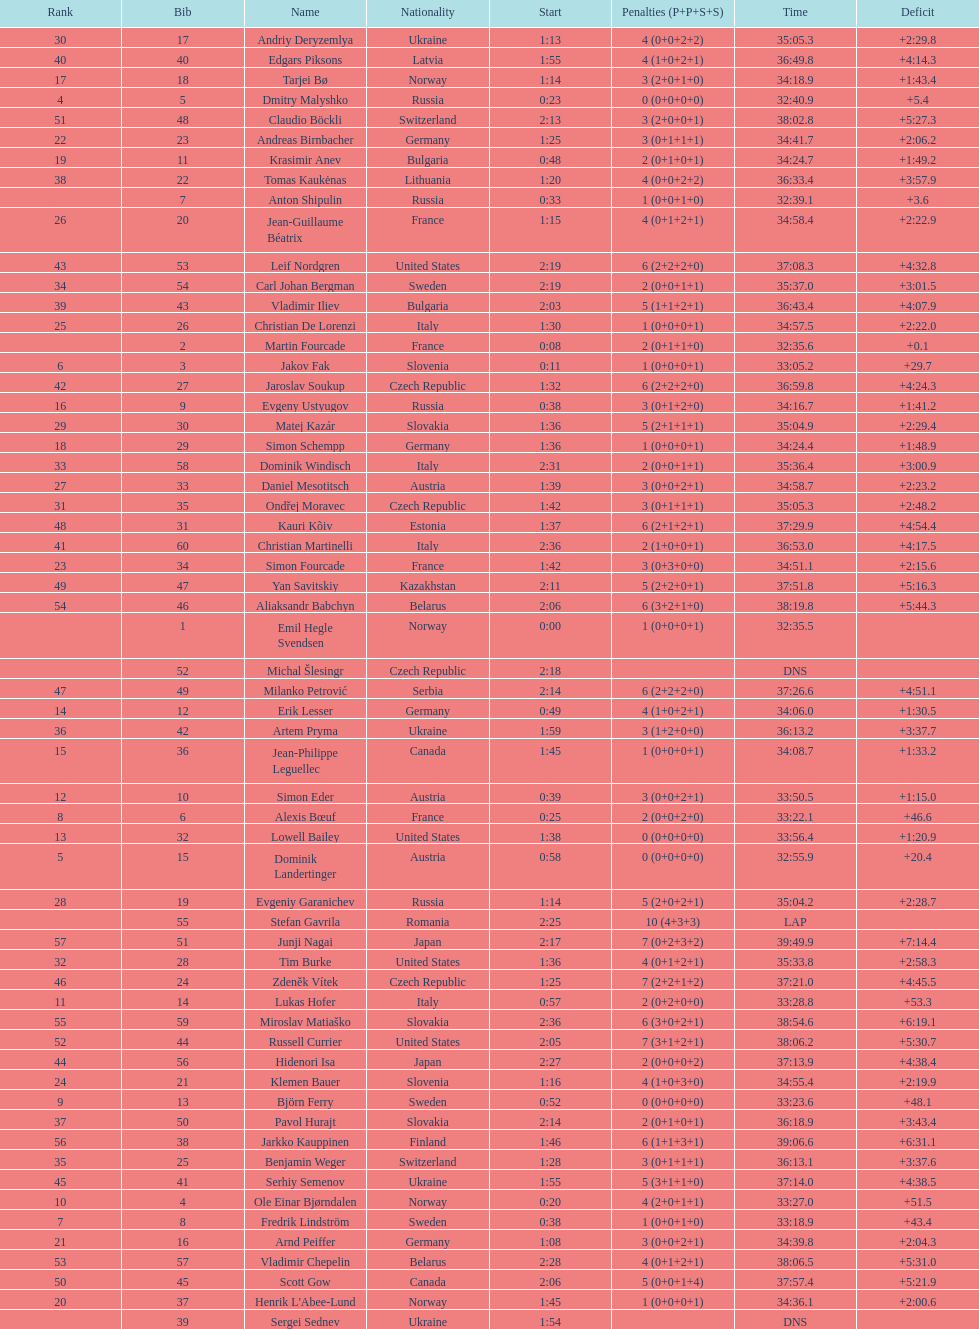Between bjorn ferry, simon elder and erik lesser - who had the most penalties? Erik Lesser. 